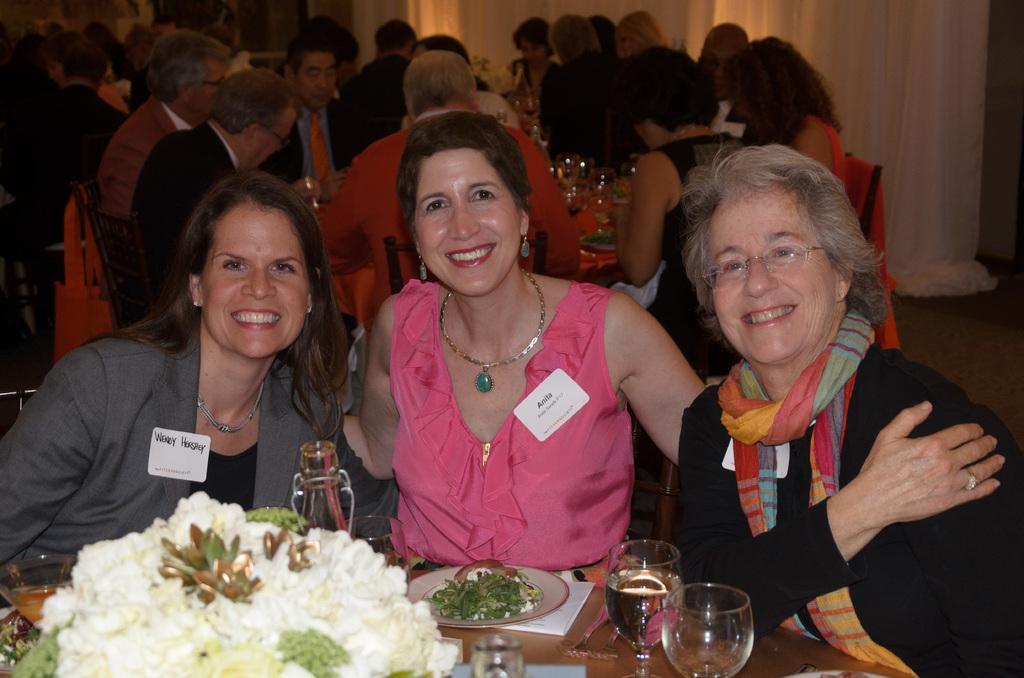Please provide a concise description of this image. In this picture there is a woman who is wearing pink dress. Beside her we can see another woman who is wearing blazer. On the right we can see old woman who is wearing black dress. Three of them are sitting on the chair near to the table. On the table we can see wine glass, water glass, vegetables, blades, paper, saltbox, tissue paper and other objects. In the background we can see the group of persons, who are eating the food. On the right background we can see white color cloth near to the wall. 